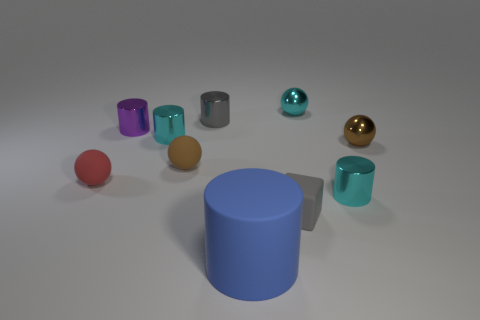Subtract 1 balls. How many balls are left? 3 Subtract all blue cylinders. How many cylinders are left? 4 Subtract all purple metallic cylinders. How many cylinders are left? 4 Subtract all yellow cylinders. Subtract all cyan balls. How many cylinders are left? 5 Subtract all spheres. How many objects are left? 6 Subtract 0 brown cylinders. How many objects are left? 10 Subtract all large red rubber things. Subtract all red balls. How many objects are left? 9 Add 2 big blue cylinders. How many big blue cylinders are left? 3 Add 3 blue rubber things. How many blue rubber things exist? 4 